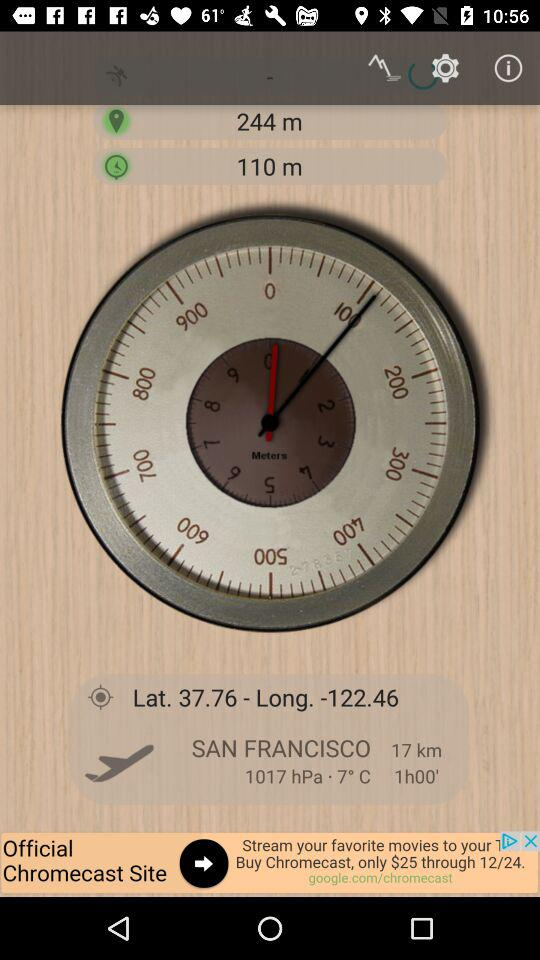What is the distance from San Francisco? The distance is 17 km. 